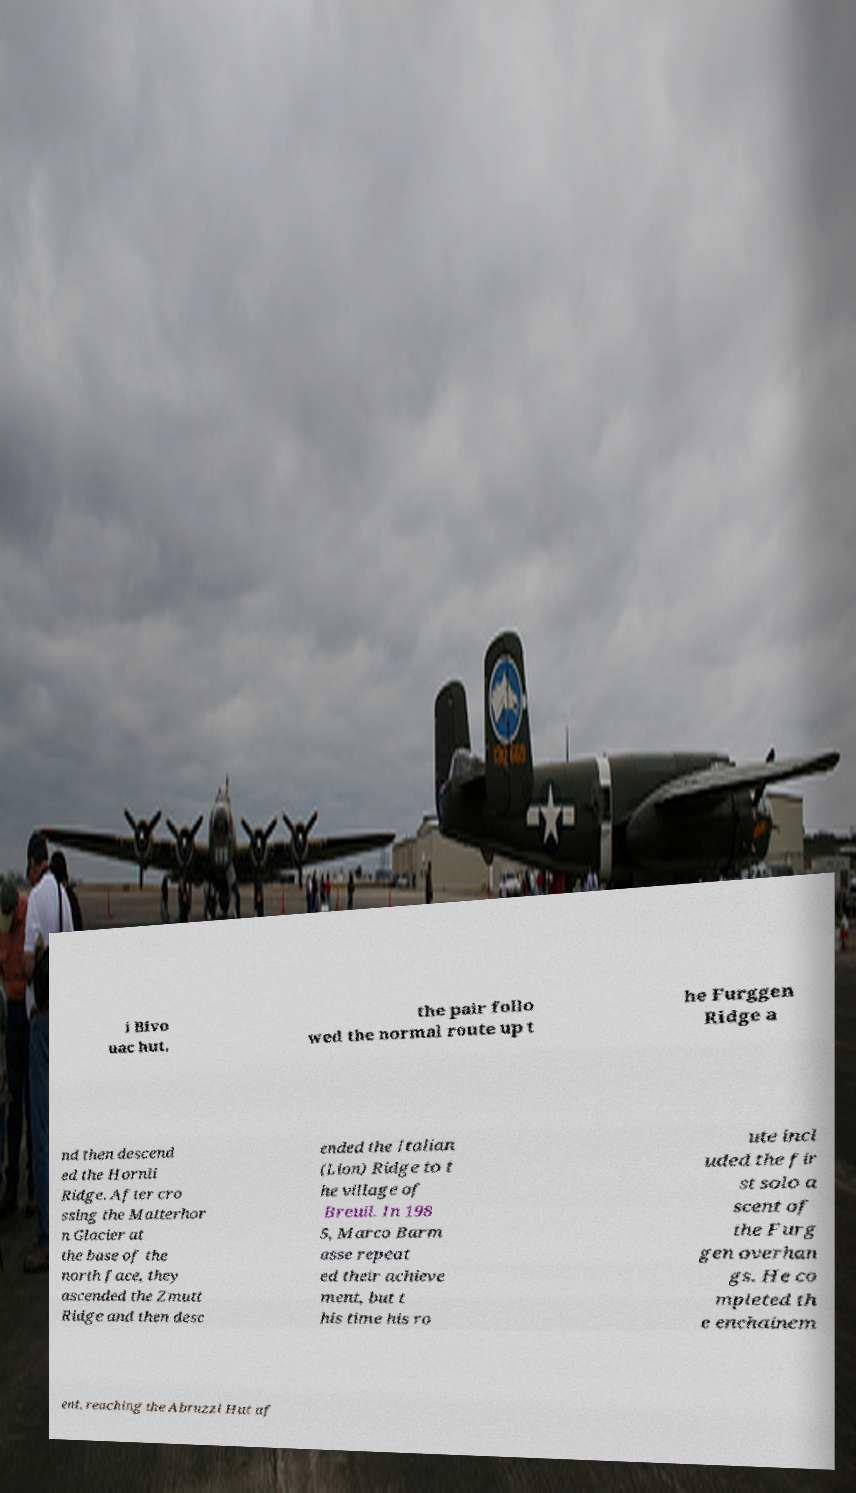Could you extract and type out the text from this image? i Bivo uac hut, the pair follo wed the normal route up t he Furggen Ridge a nd then descend ed the Hornli Ridge. After cro ssing the Matterhor n Glacier at the base of the north face, they ascended the Zmutt Ridge and then desc ended the Italian (Lion) Ridge to t he village of Breuil. In 198 5, Marco Barm asse repeat ed their achieve ment, but t his time his ro ute incl uded the fir st solo a scent of the Furg gen overhan gs. He co mpleted th e enchainem ent, reaching the Abruzzi Hut af 